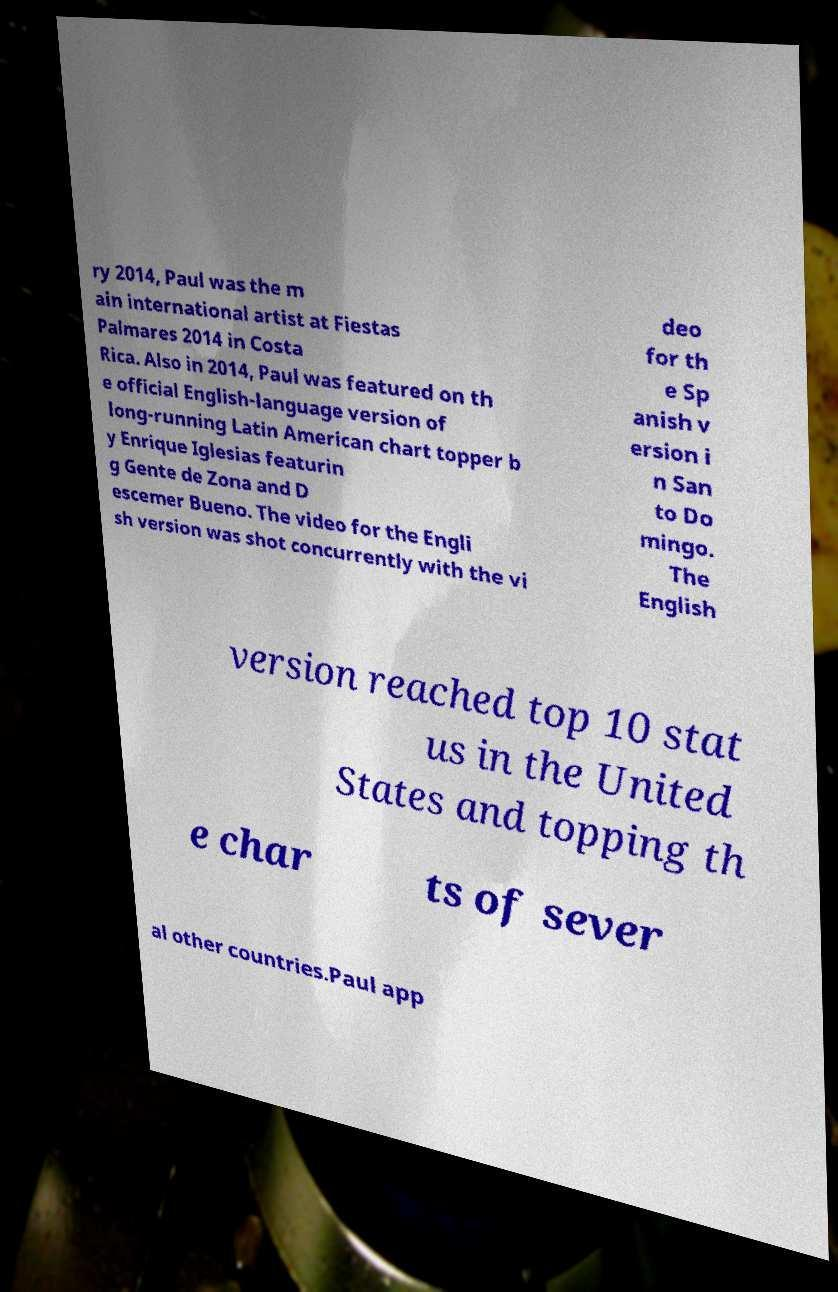I need the written content from this picture converted into text. Can you do that? ry 2014, Paul was the m ain international artist at Fiestas Palmares 2014 in Costa Rica. Also in 2014, Paul was featured on th e official English-language version of long-running Latin American chart topper b y Enrique Iglesias featurin g Gente de Zona and D escemer Bueno. The video for the Engli sh version was shot concurrently with the vi deo for th e Sp anish v ersion i n San to Do mingo. The English version reached top 10 stat us in the United States and topping th e char ts of sever al other countries.Paul app 